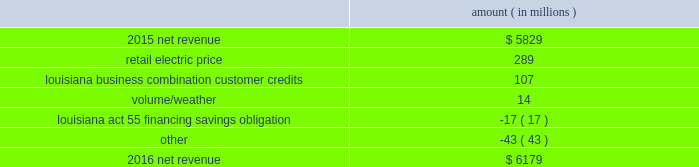Entergy corporation and subsidiaries management 2019s financial discussion and analysis palisades plants and related assets to their fair values .
See note 14 to the financial statements for further discussion of the impairment and related charges .
As a result of the entergy louisiana and entergy gulf states louisiana business combination , results of operations for 2015 also include two items that occurred in october 2015 : 1 ) a deferred tax asset and resulting net increase in tax basis of approximately $ 334 million and 2 ) a regulatory liability of $ 107 million ( $ 66 million net-of-tax ) as a result of customer credits to be realized by electric customers of entergy louisiana , consistent with the terms of the stipulated settlement in the business combination proceeding .
See note 2 to the financial statements for further discussion of the business combination and customer credits .
Results of operations for 2015 also include the sale in december 2015 of the 583 mw rhode island state energy center for a realized gain of $ 154 million ( $ 100 million net-of-tax ) on the sale and the $ 77 million ( $ 47 million net-of-tax ) write-off and regulatory charges to recognize that a portion of the assets associated with the waterford 3 replacement steam generator project is no longer probable of recovery .
See note 14 to the financial statements for further discussion of the rhode island state energy center sale .
See note 2 to the financial statements for further discussion of the waterford 3 write-off .
Net revenue utility following is an analysis of the change in net revenue comparing 2016 to 2015 .
Amount ( in millions ) .
The retail electric price variance is primarily due to : 2022 an increase in base rates at entergy arkansas , as approved by the apsc .
The new rates were effective february 24 , 2016 and began billing with the first billing cycle of april 2016 .
The increase includes an interim base rate adjustment surcharge , effective with the first billing cycle of april 2016 , to recover the incremental revenue requirement for the period february 24 , 2016 through march 31 , 2016 .
A significant portion of the increase is related to the purchase of power block 2 of the union power station ; 2022 an increase in the purchased power and capacity acquisition cost recovery rider for entergy new orleans , as approved by the city council , effective with the first billing cycle of march 2016 , primarily related to the purchase of power block 1 of the union power station ; 2022 an increase in formula rate plan revenues for entergy louisiana , implemented with the first billing cycle of march 2016 , to collect the estimated first-year revenue requirement related to the purchase of power blocks 3 and 4 of the union power station ; and 2022 an increase in revenues at entergy mississippi , as approved by the mpsc , effective with the first billing cycle of july 2016 , and an increase in revenues collected through the storm damage rider .
See note 2 to the financial statements for further discussion of the rate proceedings .
See note 14 to the financial statements for discussion of the union power station purchase .
The louisiana business combination customer credits variance is due to a regulatory liability of $ 107 million recorded by entergy in october 2015 as a result of the entergy gulf states louisiana and entergy louisiana business .
What is the percent change in net revenue from 2015 to 2016? 
Computations: ((6179 - 5829) / 5829)
Answer: 0.06004. 